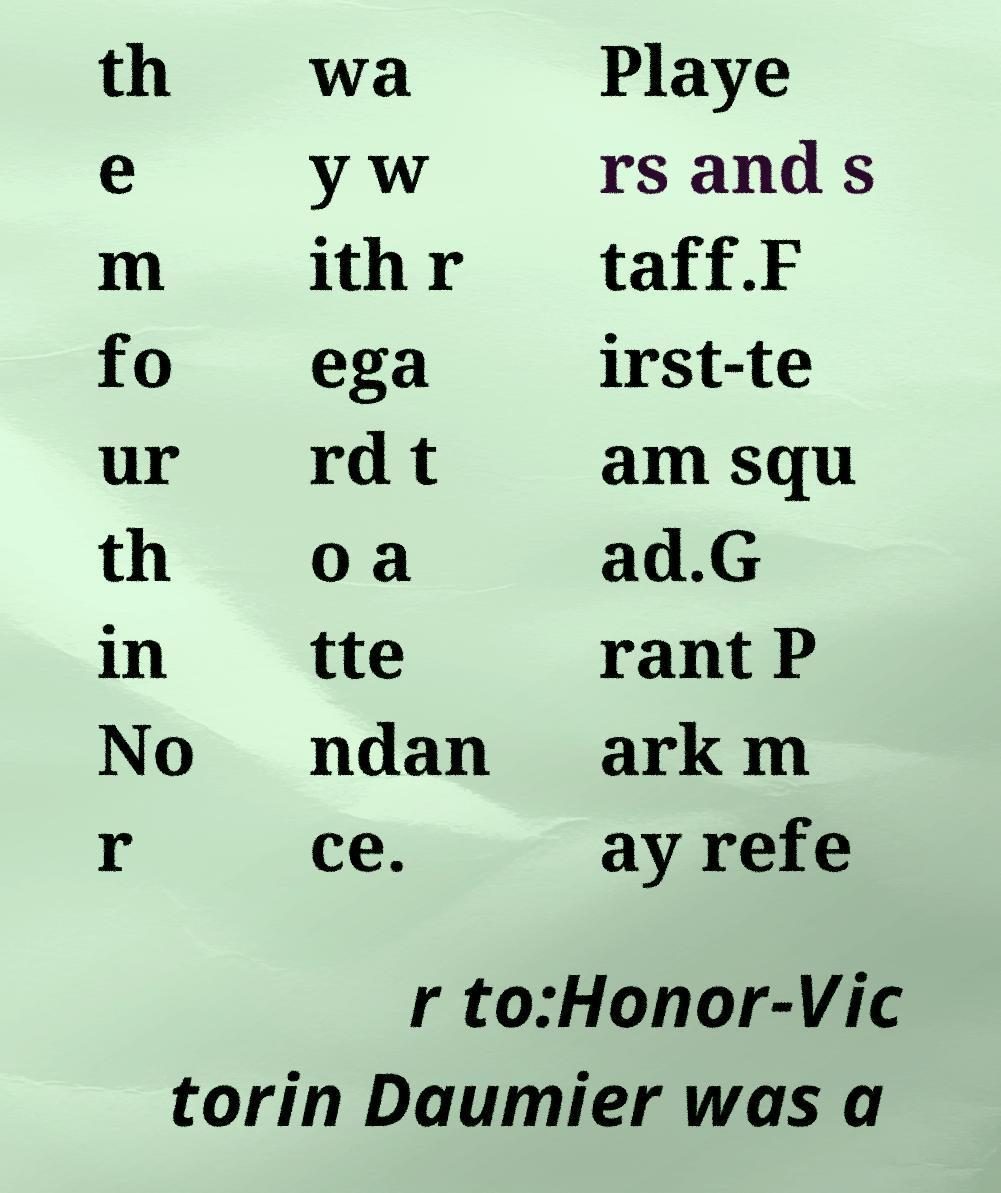Can you read and provide the text displayed in the image?This photo seems to have some interesting text. Can you extract and type it out for me? th e m fo ur th in No r wa y w ith r ega rd t o a tte ndan ce. Playe rs and s taff.F irst-te am squ ad.G rant P ark m ay refe r to:Honor-Vic torin Daumier was a 